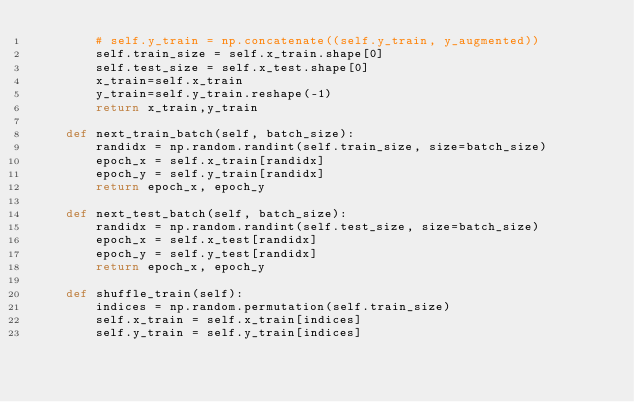<code> <loc_0><loc_0><loc_500><loc_500><_Python_>        # self.y_train = np.concatenate((self.y_train, y_augmented))
        self.train_size = self.x_train.shape[0]
        self.test_size = self.x_test.shape[0]
        x_train=self.x_train
        y_train=self.y_train.reshape(-1)
        return x_train,y_train

    def next_train_batch(self, batch_size):
        randidx = np.random.randint(self.train_size, size=batch_size)
        epoch_x = self.x_train[randidx]
        epoch_y = self.y_train[randidx]
        return epoch_x, epoch_y

    def next_test_batch(self, batch_size):
        randidx = np.random.randint(self.test_size, size=batch_size)
        epoch_x = self.x_test[randidx]
        epoch_y = self.y_test[randidx]
        return epoch_x, epoch_y

    def shuffle_train(self):
        indices = np.random.permutation(self.train_size)
        self.x_train = self.x_train[indices]
        self.y_train = self.y_train[indices]</code> 